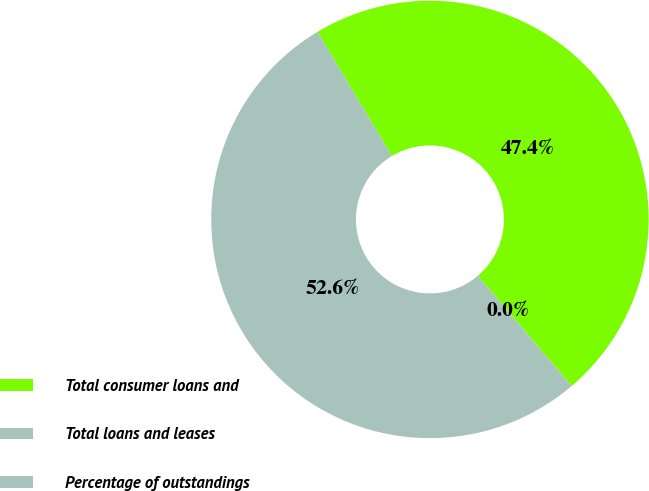<chart> <loc_0><loc_0><loc_500><loc_500><pie_chart><fcel>Total consumer loans and<fcel>Total loans and leases<fcel>Percentage of outstandings<nl><fcel>47.38%<fcel>52.61%<fcel>0.01%<nl></chart> 